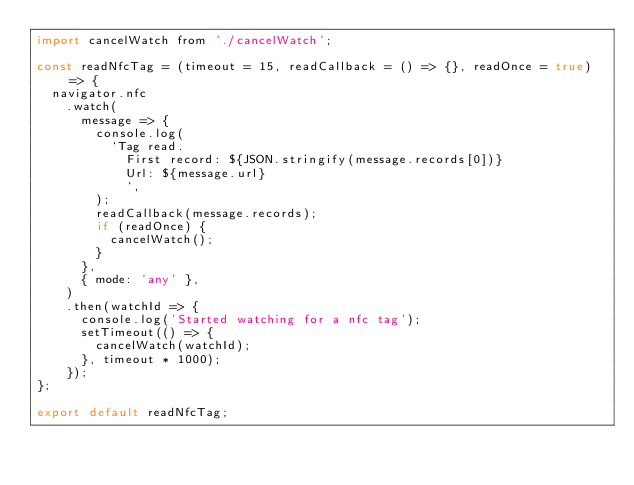Convert code to text. <code><loc_0><loc_0><loc_500><loc_500><_JavaScript_>import cancelWatch from './cancelWatch';

const readNfcTag = (timeout = 15, readCallback = () => {}, readOnce = true) => {
  navigator.nfc
    .watch(
      message => {
        console.log(
          `Tag read.
            First record: ${JSON.stringify(message.records[0])}
            Url: ${message.url}
            `,
        );
        readCallback(message.records);
        if (readOnce) {
          cancelWatch();
        }
      },
      { mode: 'any' },
    )
    .then(watchId => {
      console.log('Started watching for a nfc tag');
      setTimeout(() => {
        cancelWatch(watchId);
      }, timeout * 1000);
    });
};

export default readNfcTag;
</code> 